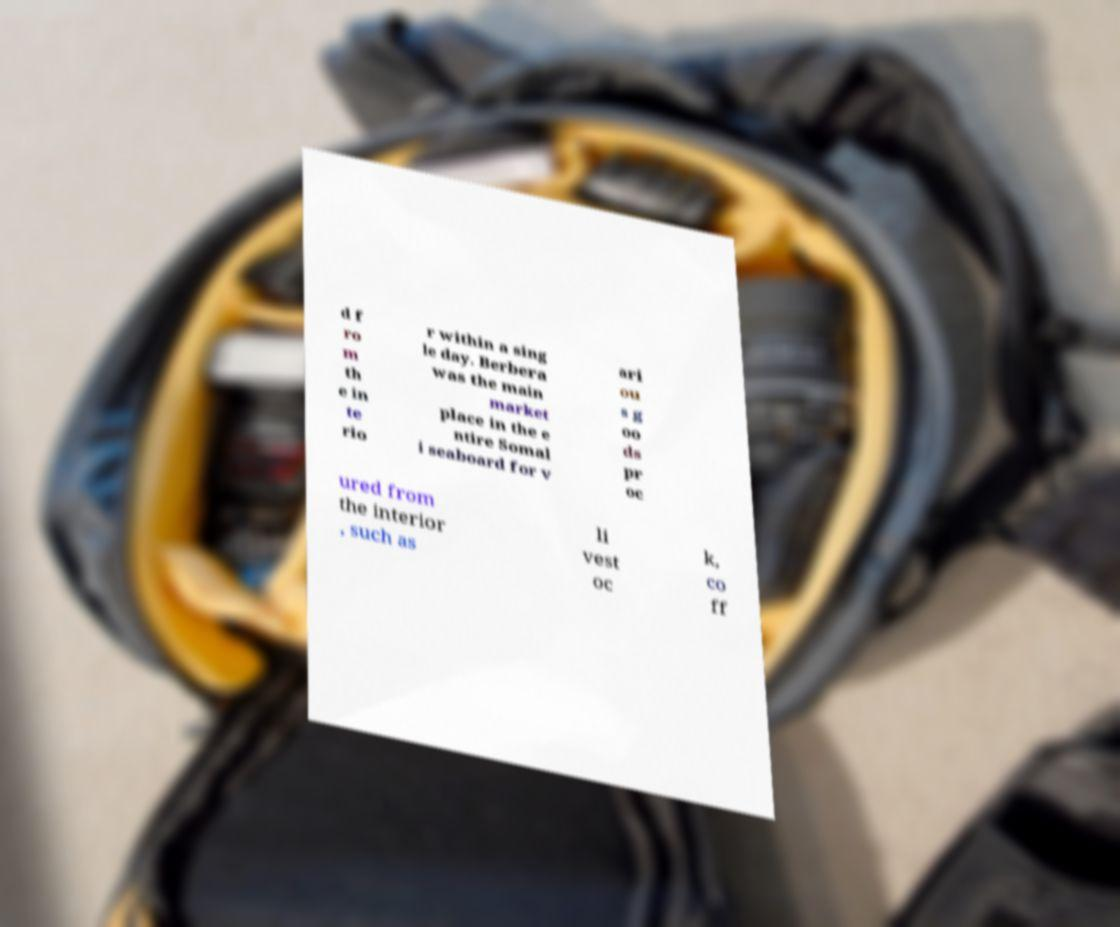What messages or text are displayed in this image? I need them in a readable, typed format. d f ro m th e in te rio r within a sing le day. Berbera was the main market place in the e ntire Somal i seaboard for v ari ou s g oo ds pr oc ured from the interior , such as li vest oc k, co ff 